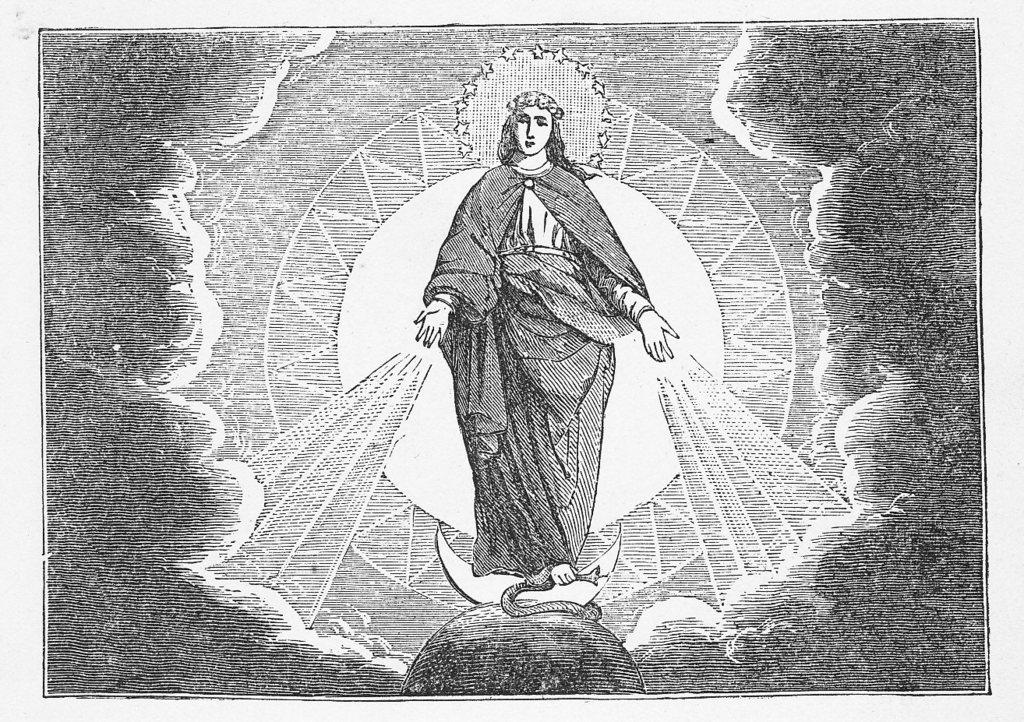What type of artwork is featured in the image? The image contains a pencil sketch. What is the subject matter of the sketch? The sketch depicts a man standing on the half moon. What is the man in the sketch doing? The man is giving blessings with two hands. What can be seen in the background of the sketch? Clouds are present around the man in the sketch. What type of liquid is being poured by the man in the sketch? There is no liquid being poured in the sketch; the man is giving blessings with two hands. How many apples are visible in the sketch? There are no apples present in the sketch; it features a man standing on the half moon and giving blessings. 